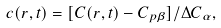Convert formula to latex. <formula><loc_0><loc_0><loc_500><loc_500>c ( { r } , t ) = [ C ( { r } , t ) - C _ { p \beta } ] / \Delta C _ { \alpha } ,</formula> 